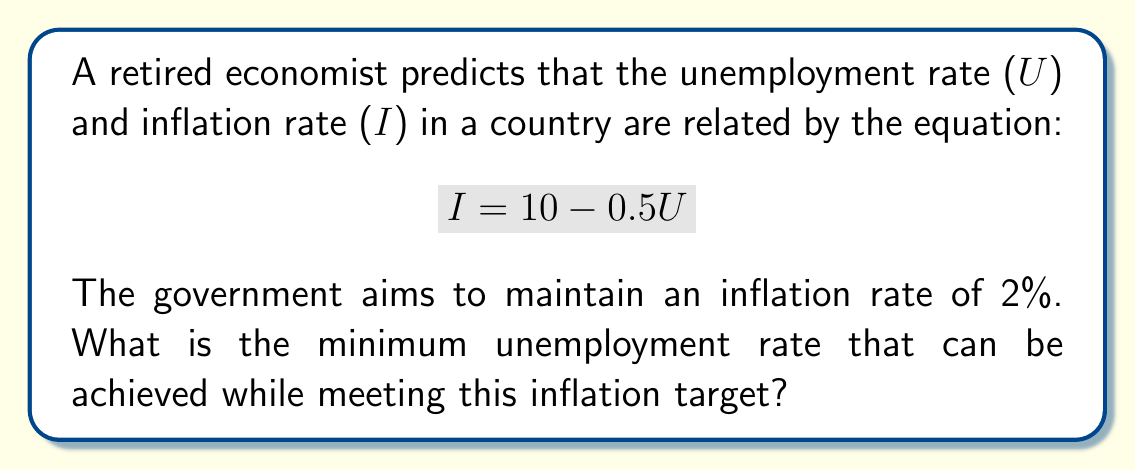Teach me how to tackle this problem. To solve this problem, we need to follow these steps:

1) We're given the relationship between unemployment (U) and inflation (I):
   $$ I = 10 - 0.5U $$

2) The government wants to maintain an inflation rate of 2%. So we can substitute this into our equation:
   $$ 2 = 10 - 0.5U $$

3) Now we need to solve this equation for U:
   $$ 0.5U = 10 - 2 $$
   $$ 0.5U = 8 $$

4) Divide both sides by 0.5:
   $$ U = 8 \div 0.5 = 16 $$

5) Therefore, the minimum unemployment rate that can be achieved while maintaining an inflation rate of 2% is 16%.

This result demonstrates the trade-off between unemployment and inflation, often referred to as the Phillips curve in economics. In this case, to keep inflation low, a relatively high unemployment rate must be tolerated.
Answer: The minimum unemployment rate that can be achieved while maintaining an inflation rate of 2% is 16%. 